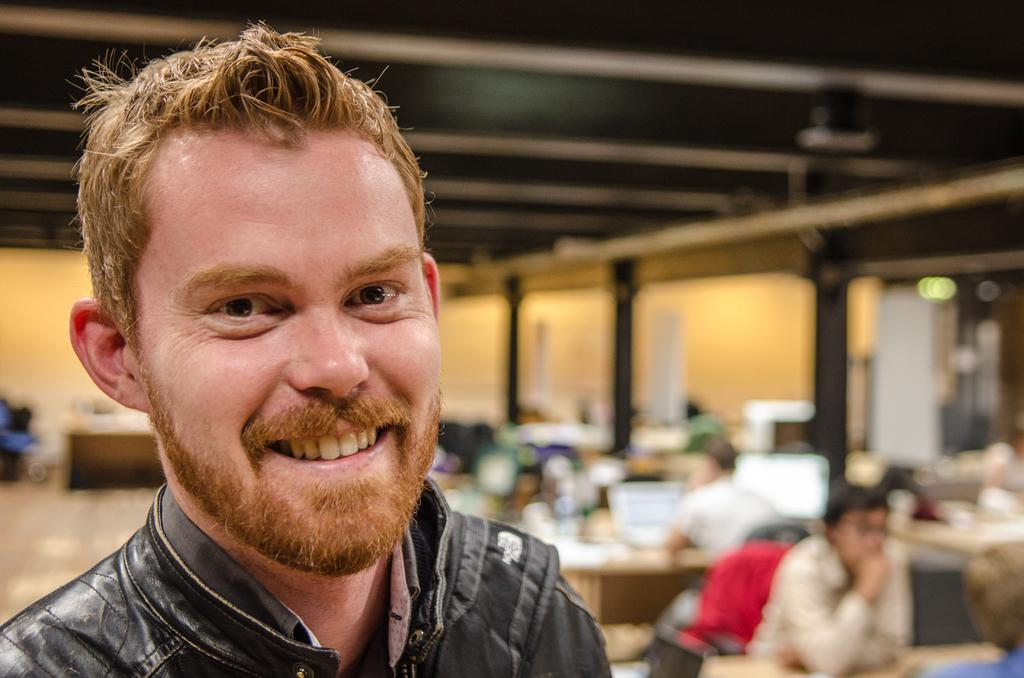What is the main subject in the image? There is a person standing in the image. Can you describe the background of the image? The background of the image is blurred. What hobbies does the actor in the image enjoy? There is no actor present in the image, and no information about the person's hobbies is provided. 